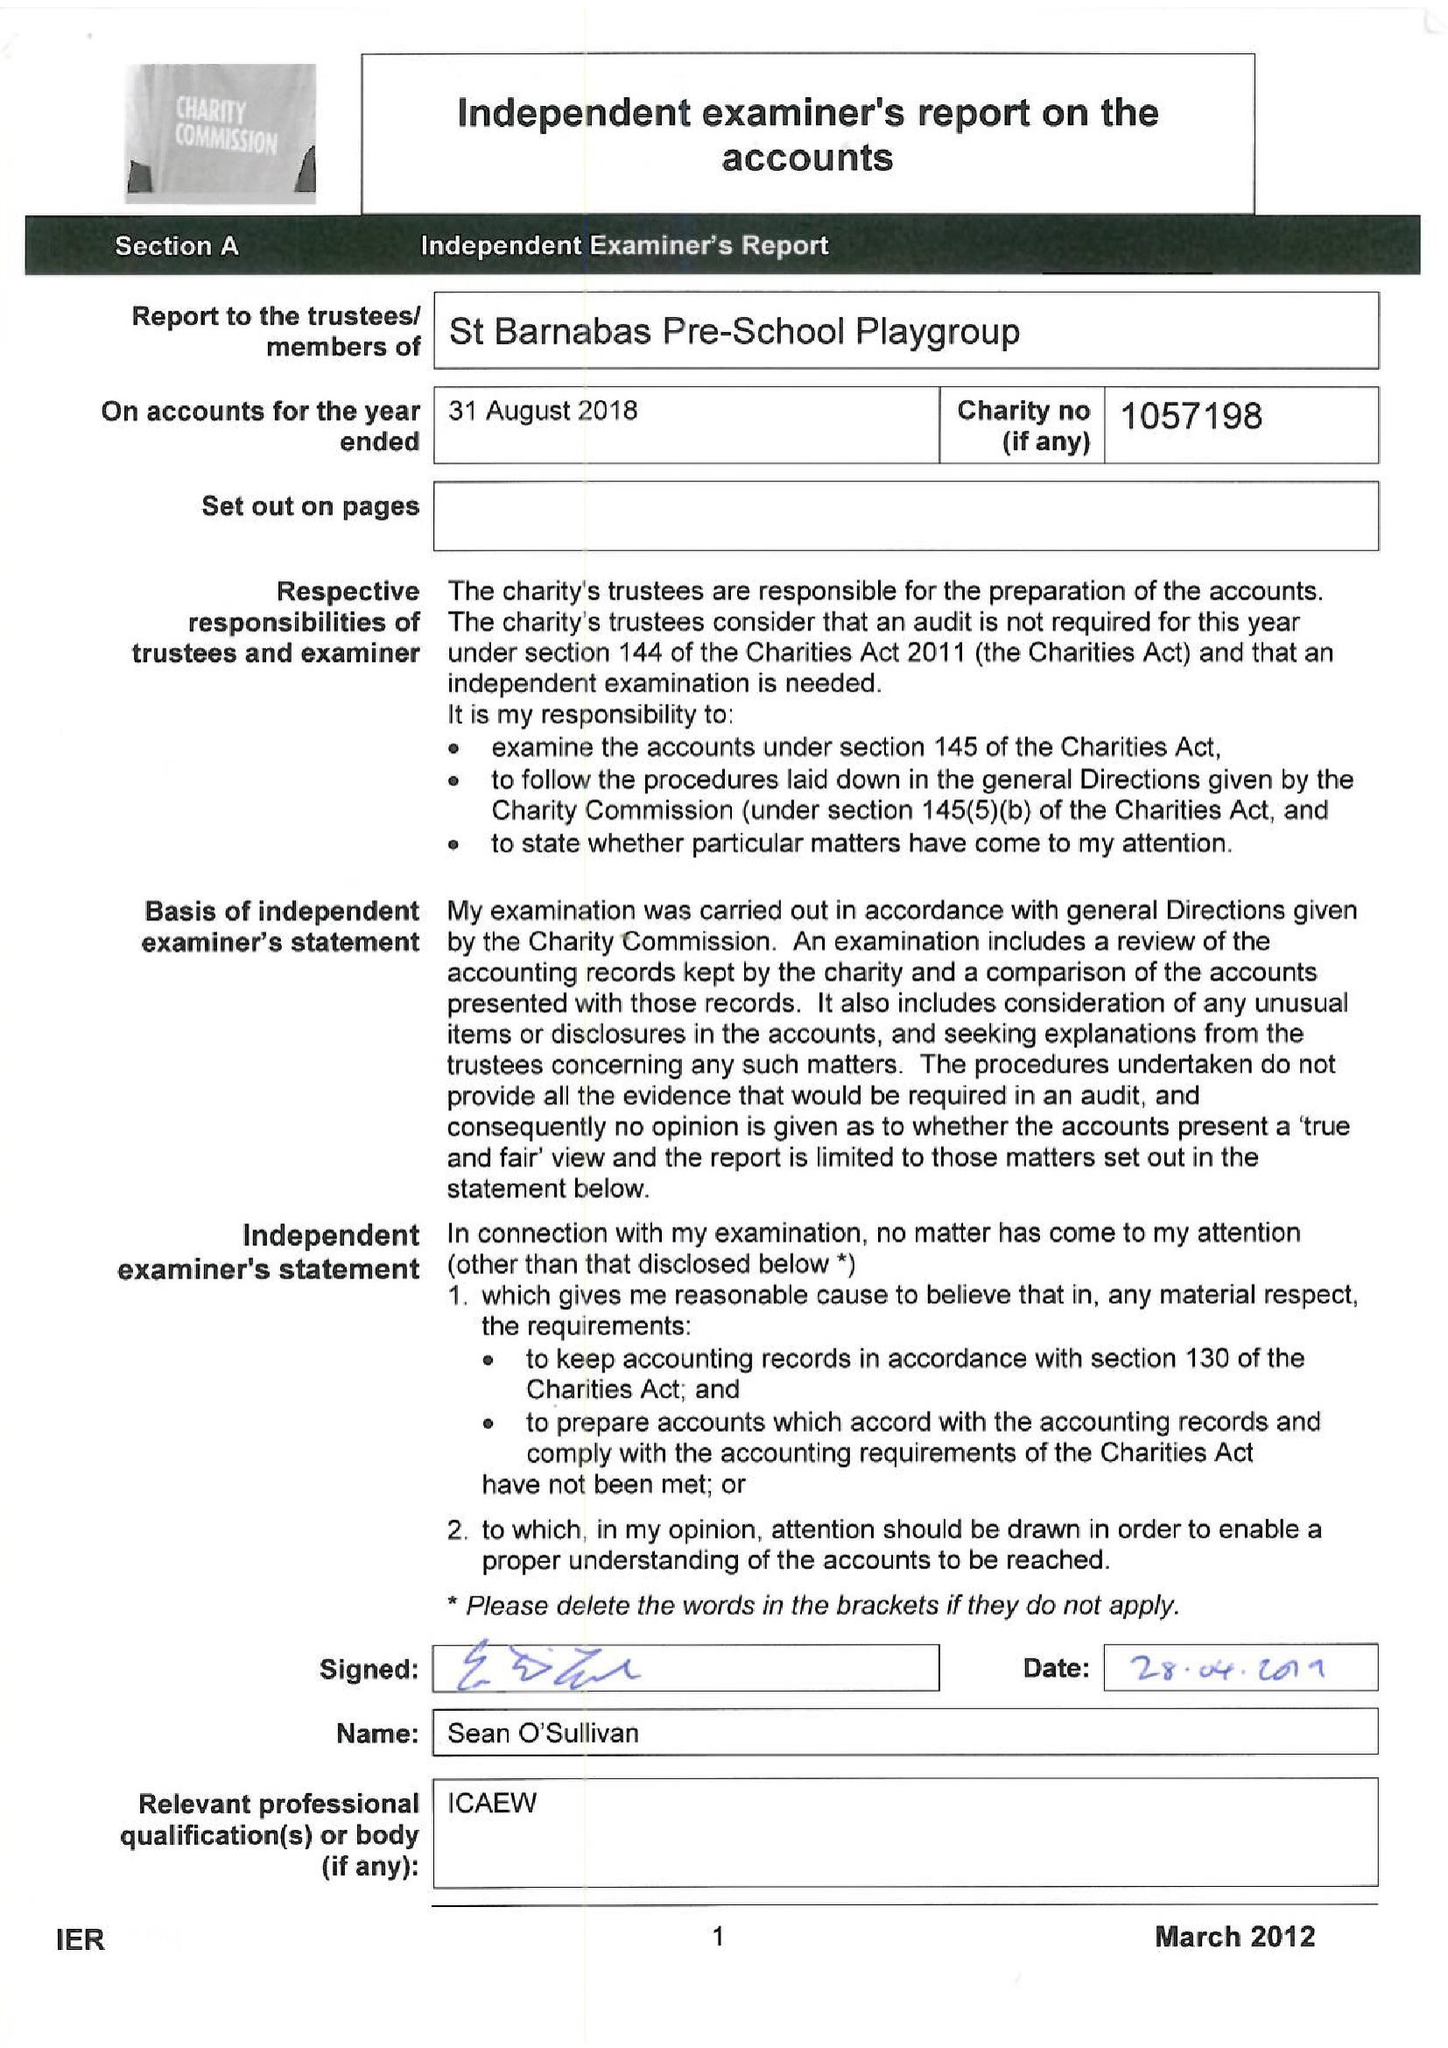What is the value for the address__postcode?
Answer the question using a single word or phrase. W5 1QG 